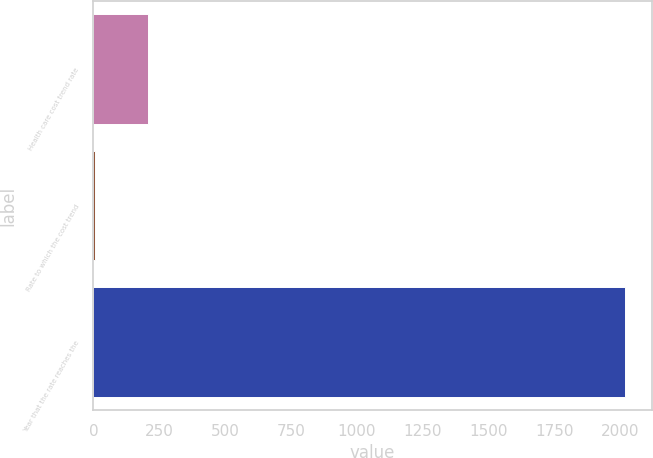Convert chart. <chart><loc_0><loc_0><loc_500><loc_500><bar_chart><fcel>Health care cost trend rate<fcel>Rate to which the cost trend<fcel>Year that the rate reaches the<nl><fcel>205.84<fcel>4.49<fcel>2018<nl></chart> 